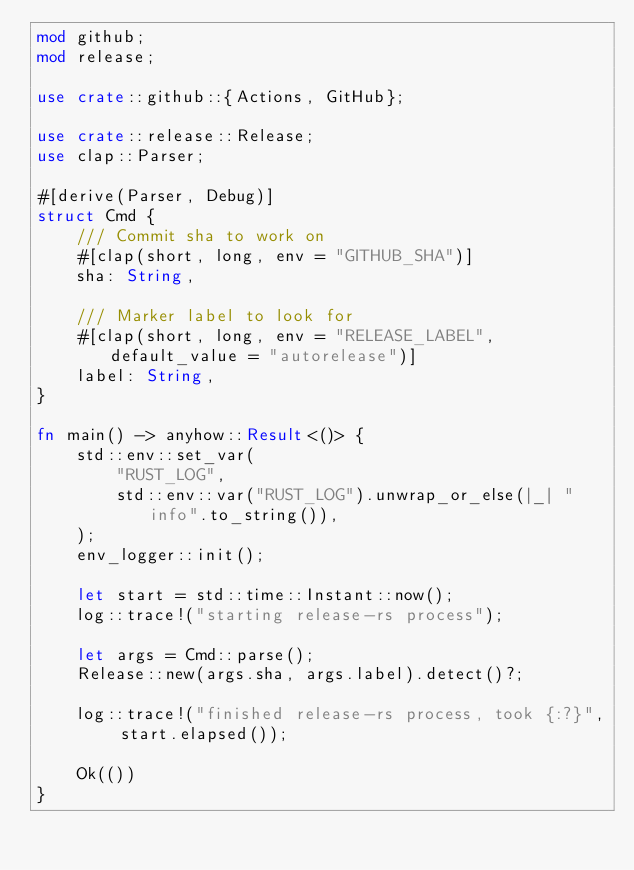<code> <loc_0><loc_0><loc_500><loc_500><_Rust_>mod github;
mod release;

use crate::github::{Actions, GitHub};

use crate::release::Release;
use clap::Parser;

#[derive(Parser, Debug)]
struct Cmd {
    /// Commit sha to work on
    #[clap(short, long, env = "GITHUB_SHA")]
    sha: String,

    /// Marker label to look for
    #[clap(short, long, env = "RELEASE_LABEL", default_value = "autorelease")]
    label: String,
}

fn main() -> anyhow::Result<()> {
    std::env::set_var(
        "RUST_LOG",
        std::env::var("RUST_LOG").unwrap_or_else(|_| "info".to_string()),
    );
    env_logger::init();

    let start = std::time::Instant::now();
    log::trace!("starting release-rs process");

    let args = Cmd::parse();
    Release::new(args.sha, args.label).detect()?;

    log::trace!("finished release-rs process, took {:?}", start.elapsed());

    Ok(())
}
</code> 